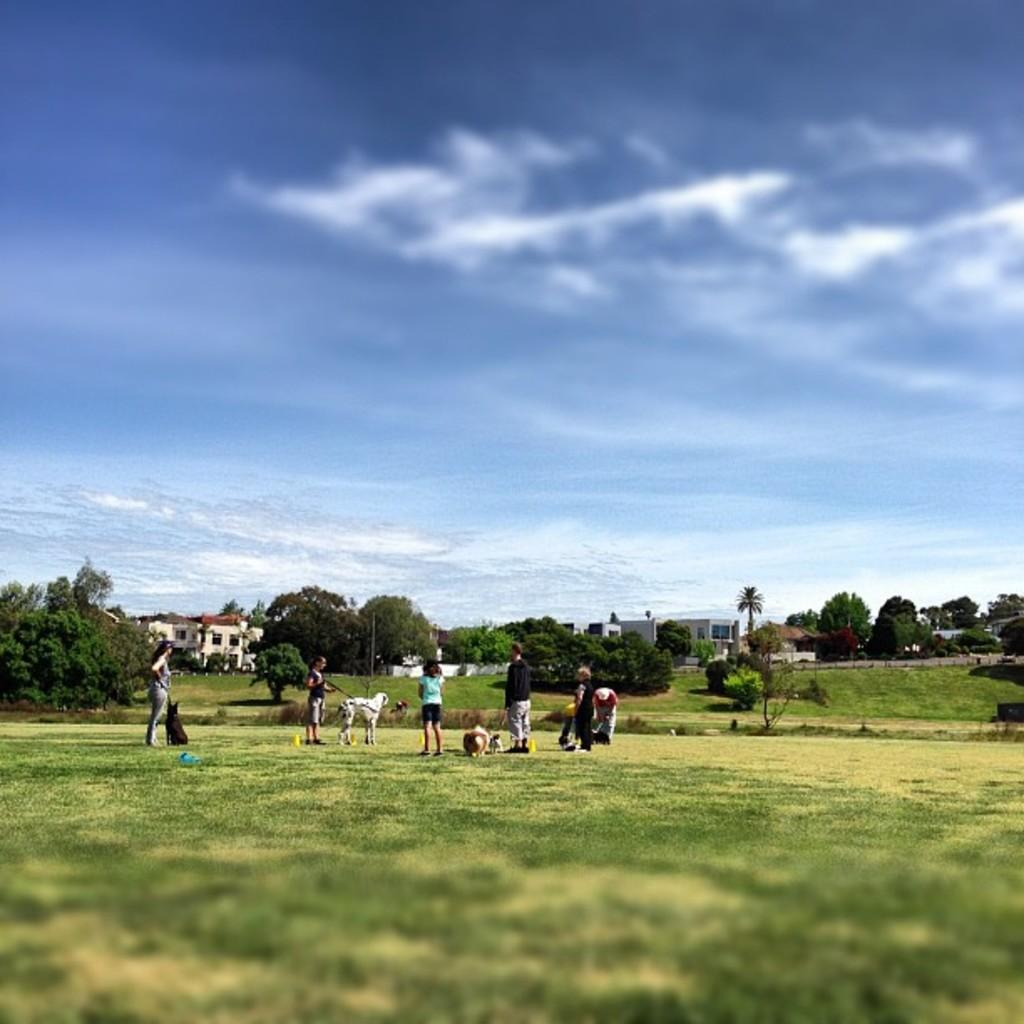What is present on the ground in the image? There are persons and animals on the ground in the image. What type of vegetation is on the ground? The ground has grass. What can be seen in the background of the image? There are trees and buildings in the background. What is the condition of the ground in the background? The ground in the background also has grass. What is visible in the sky? There are clouds in the blue sky. How many thumbs can be seen on the animals in the image? There are no thumbs visible on the animals in the image, as animals do not have thumbs. What type of crib is present in the image? There is no crib present in the image. 